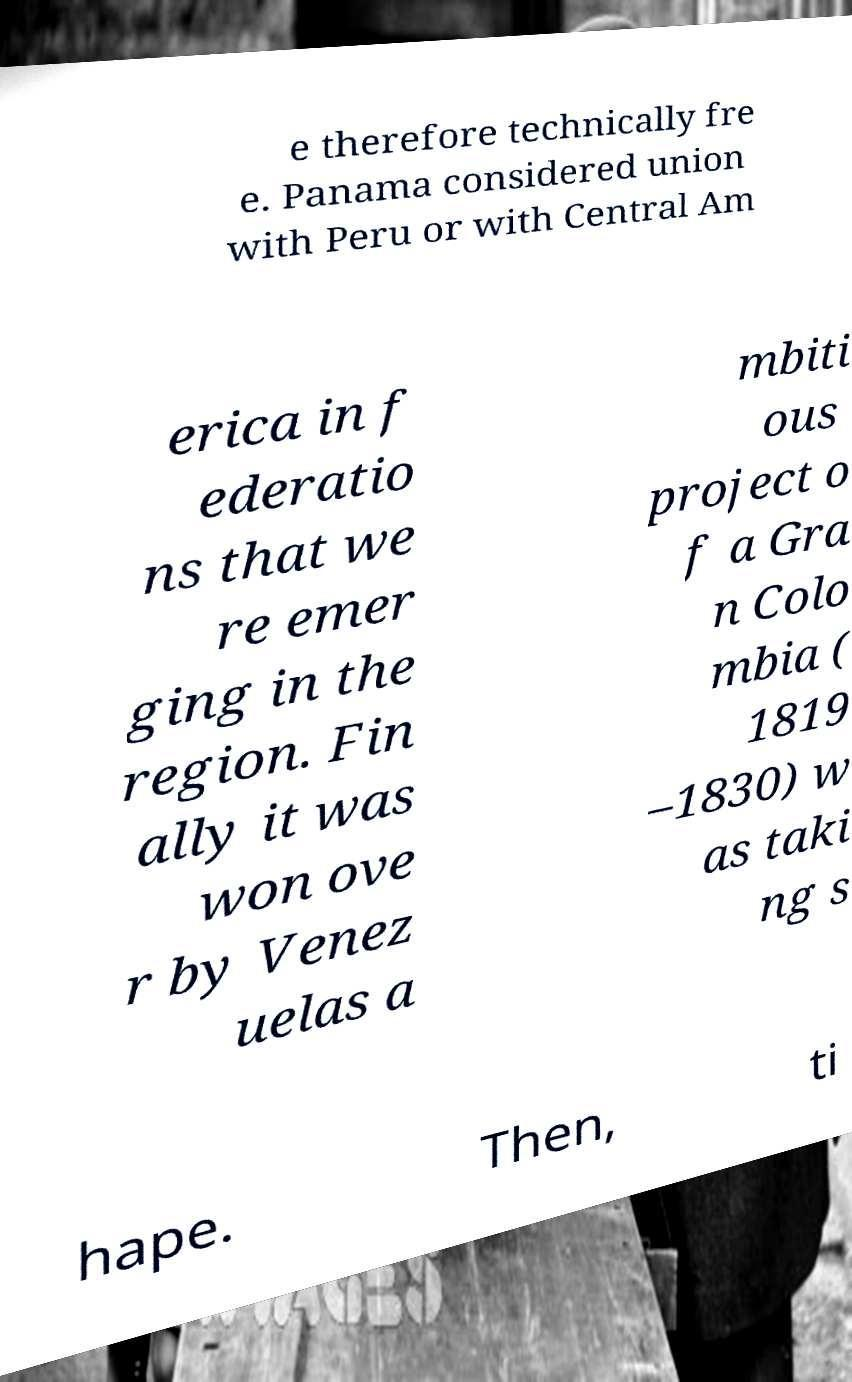Could you assist in decoding the text presented in this image and type it out clearly? e therefore technically fre e. Panama considered union with Peru or with Central Am erica in f ederatio ns that we re emer ging in the region. Fin ally it was won ove r by Venez uelas a mbiti ous project o f a Gra n Colo mbia ( 1819 –1830) w as taki ng s hape. Then, ti 